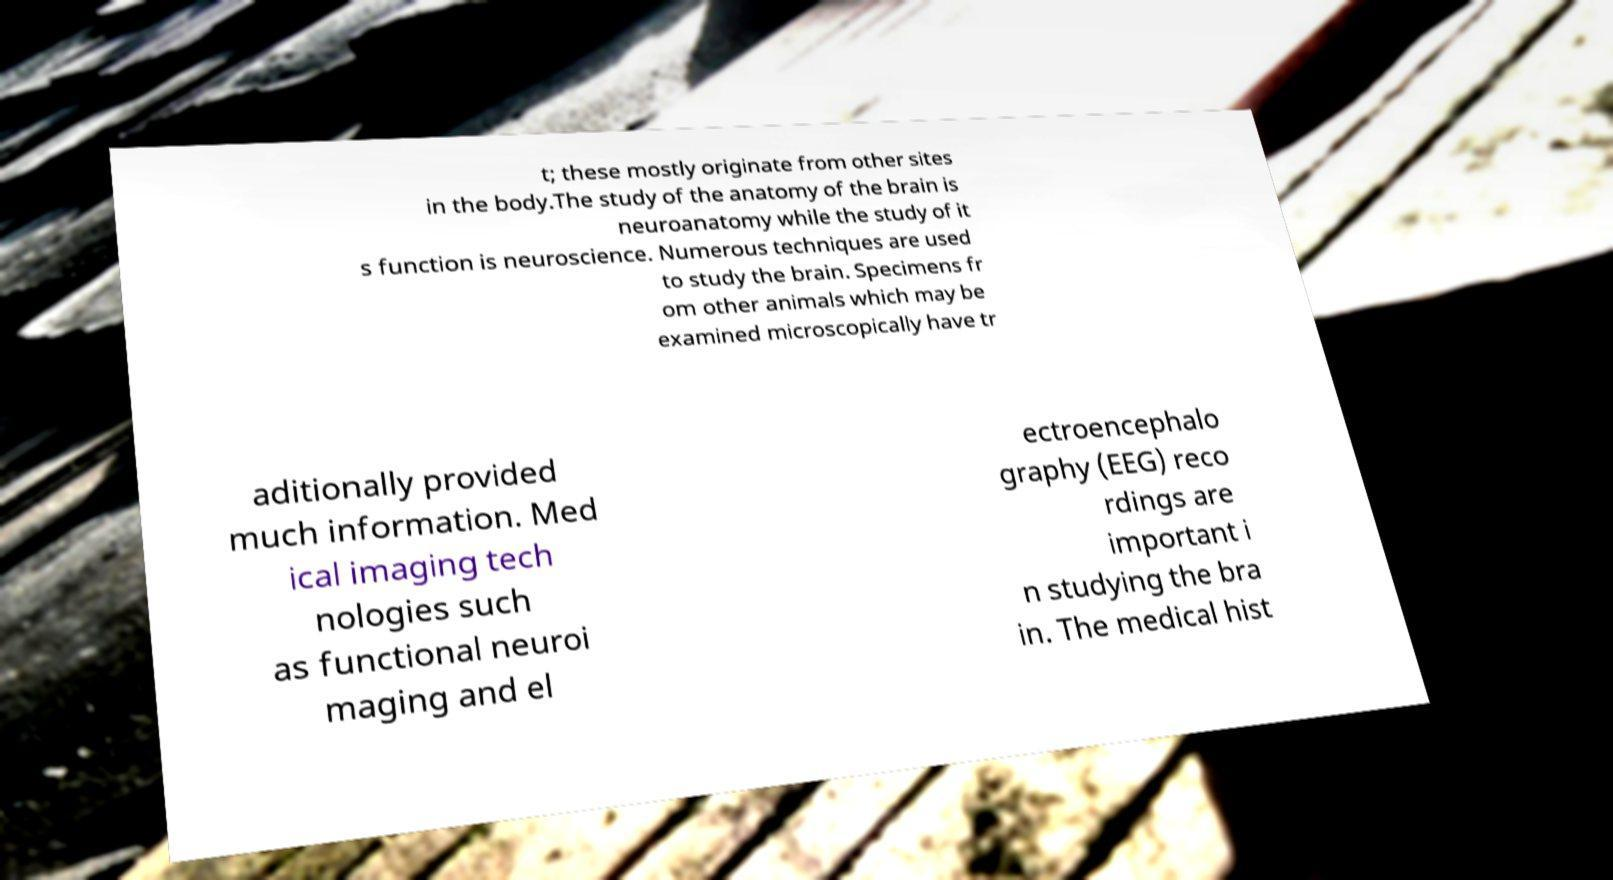What messages or text are displayed in this image? I need them in a readable, typed format. t; these mostly originate from other sites in the body.The study of the anatomy of the brain is neuroanatomy while the study of it s function is neuroscience. Numerous techniques are used to study the brain. Specimens fr om other animals which may be examined microscopically have tr aditionally provided much information. Med ical imaging tech nologies such as functional neuroi maging and el ectroencephalo graphy (EEG) reco rdings are important i n studying the bra in. The medical hist 